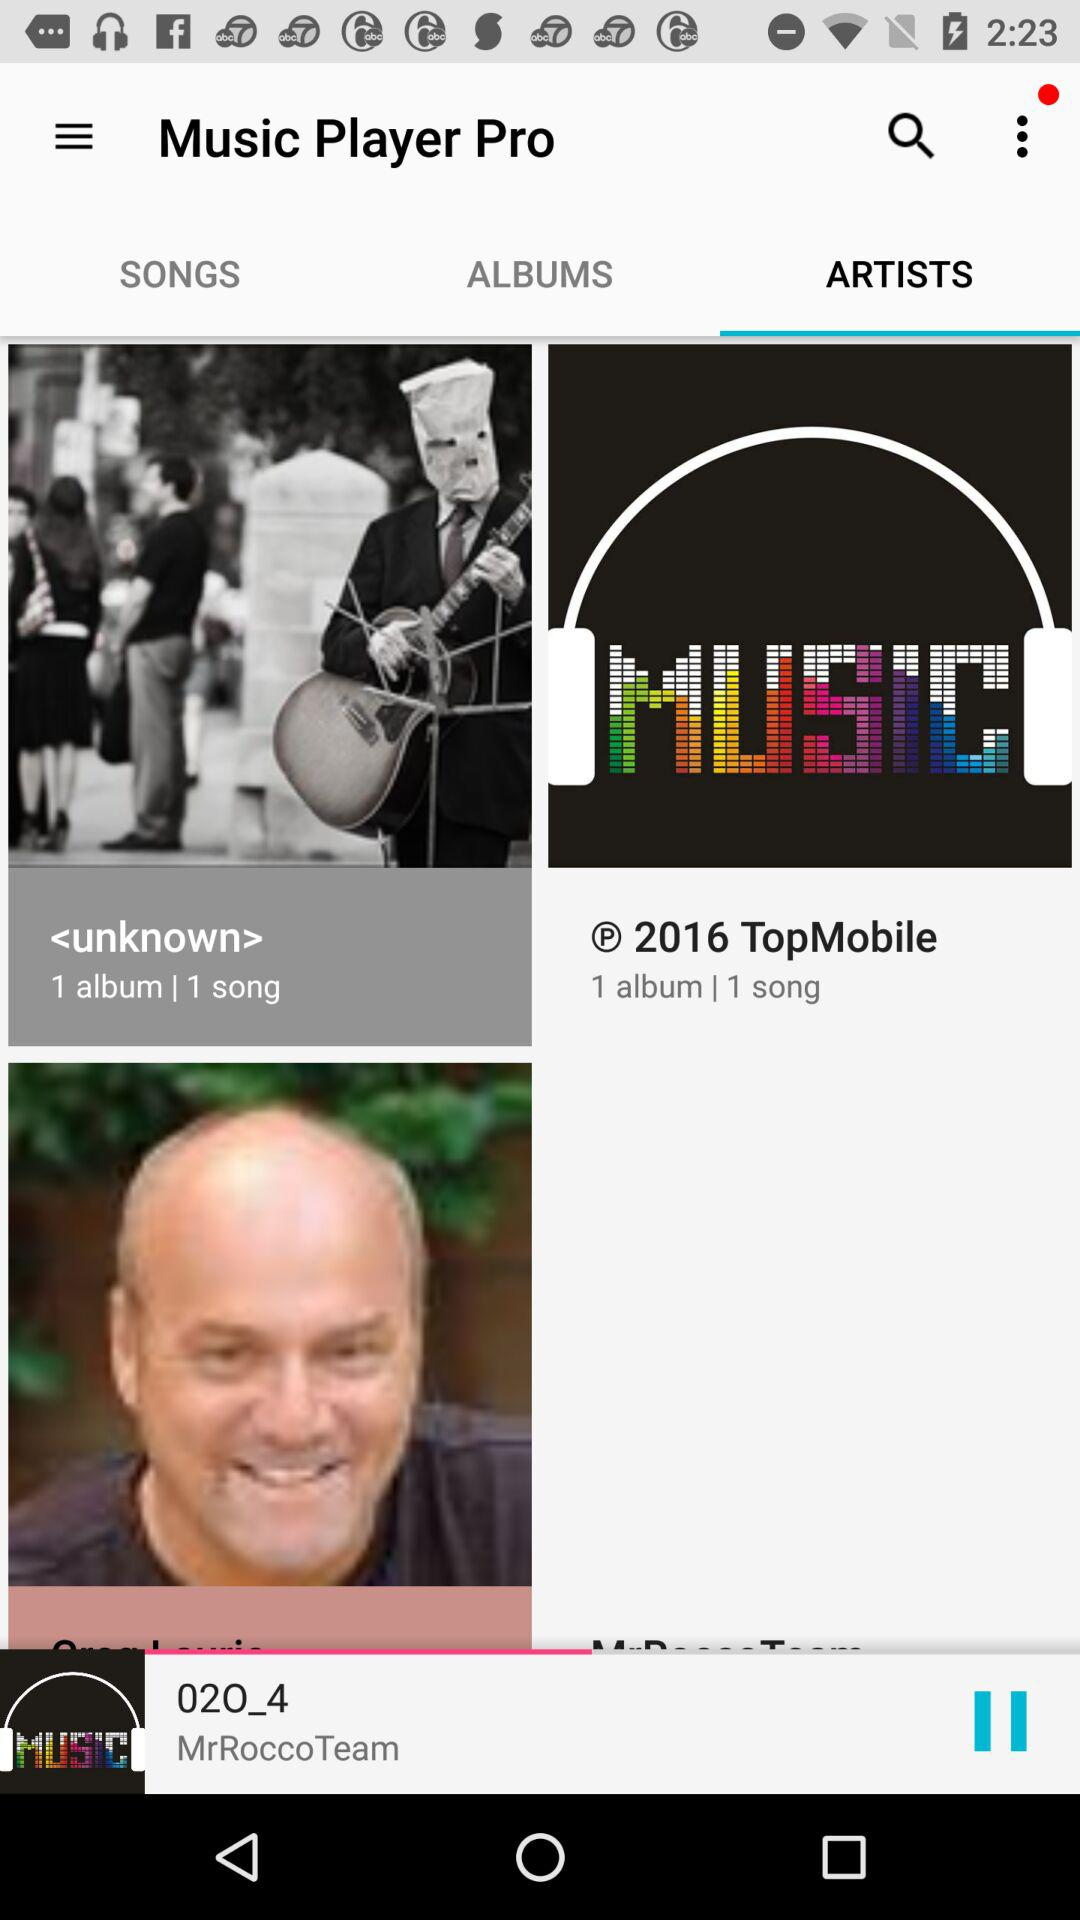Who is the artist of "02O_4"? The artist of "02O_4" is "MrRoccoTeam". 